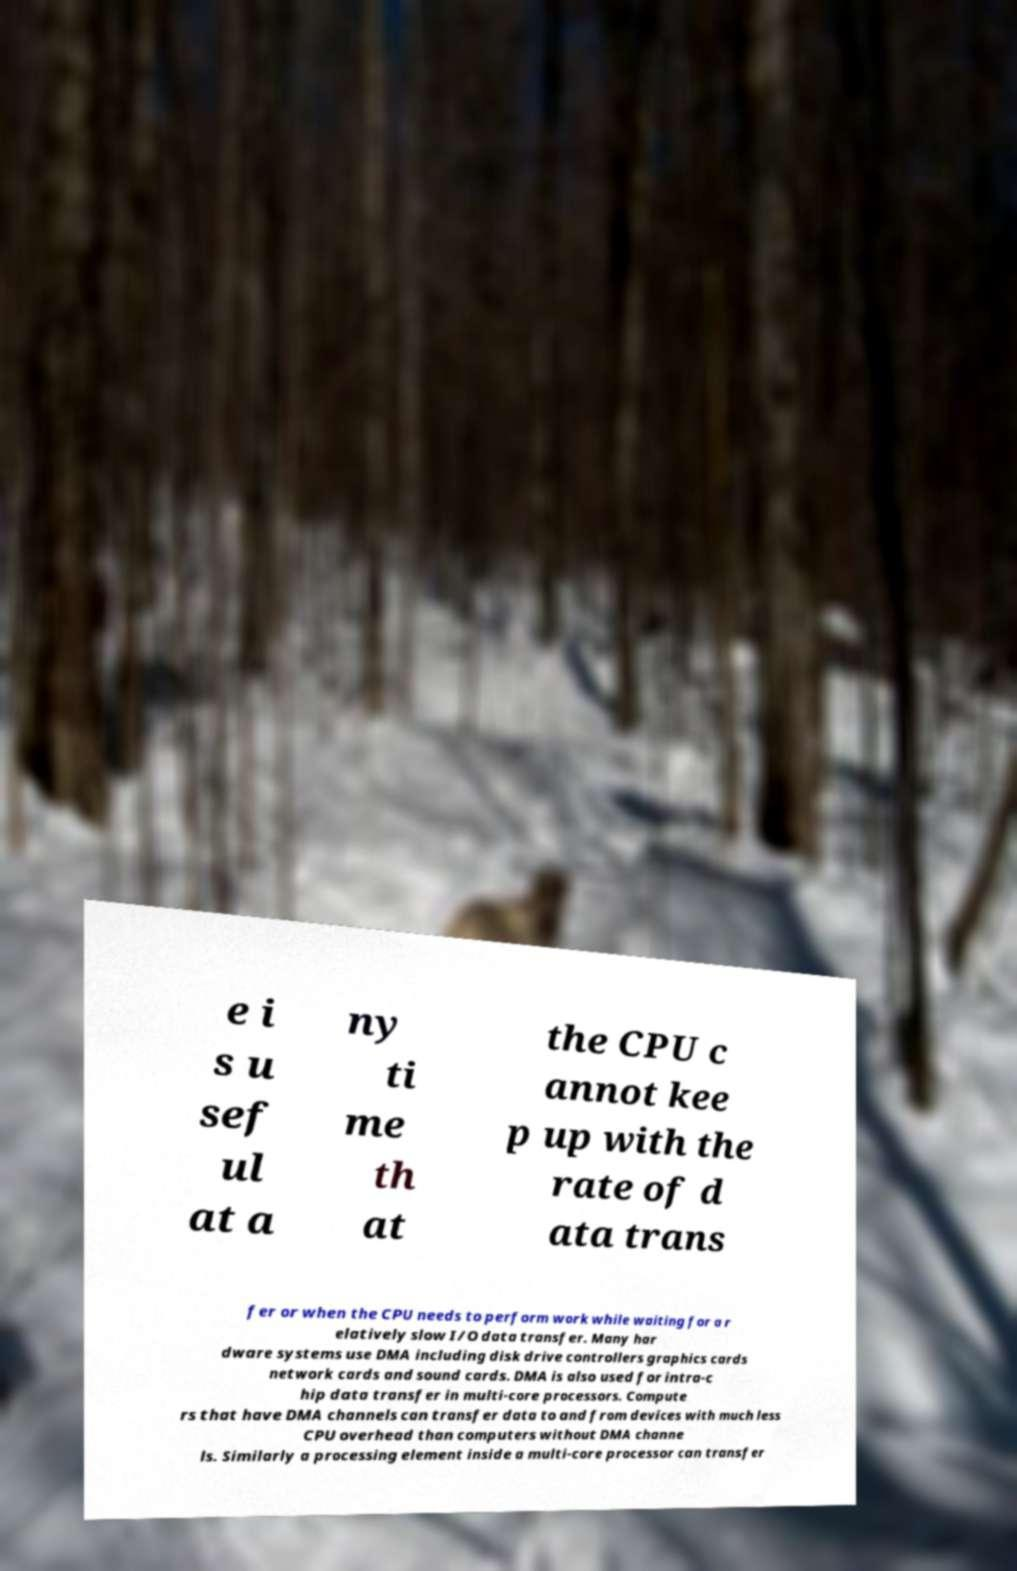What messages or text are displayed in this image? I need them in a readable, typed format. e i s u sef ul at a ny ti me th at the CPU c annot kee p up with the rate of d ata trans fer or when the CPU needs to perform work while waiting for a r elatively slow I/O data transfer. Many har dware systems use DMA including disk drive controllers graphics cards network cards and sound cards. DMA is also used for intra-c hip data transfer in multi-core processors. Compute rs that have DMA channels can transfer data to and from devices with much less CPU overhead than computers without DMA channe ls. Similarly a processing element inside a multi-core processor can transfer 